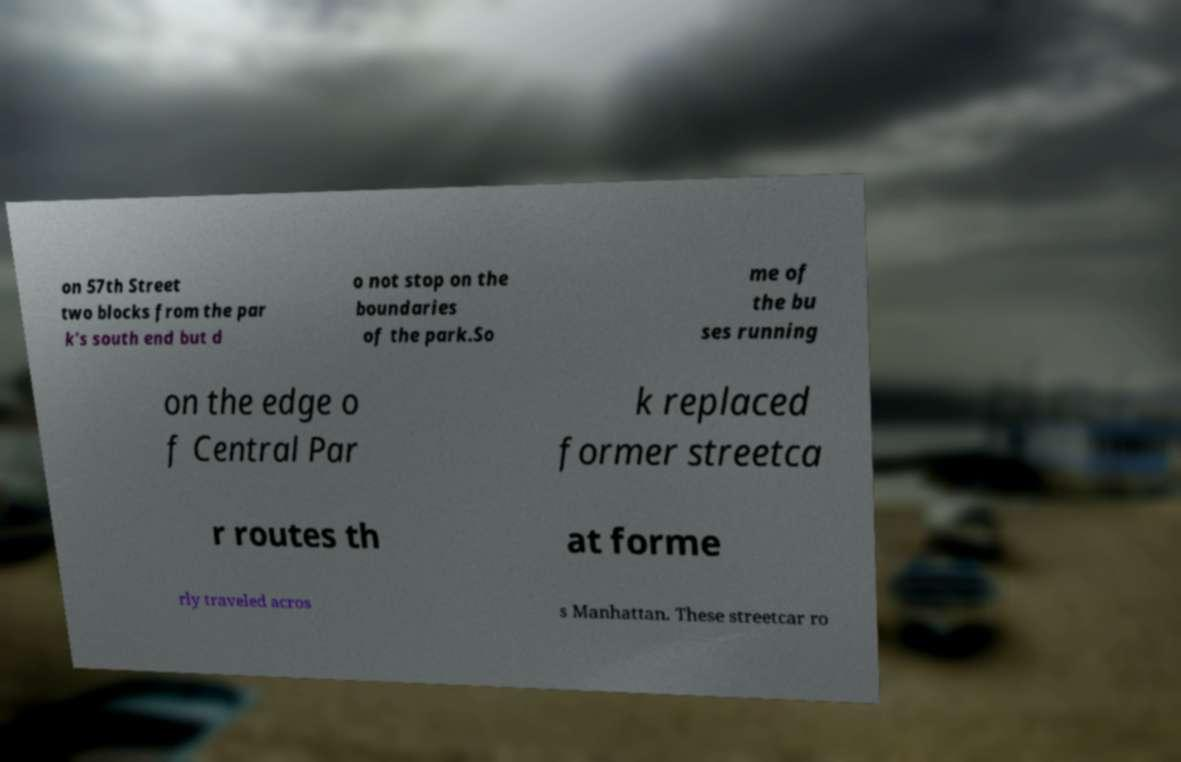Could you assist in decoding the text presented in this image and type it out clearly? on 57th Street two blocks from the par k's south end but d o not stop on the boundaries of the park.So me of the bu ses running on the edge o f Central Par k replaced former streetca r routes th at forme rly traveled acros s Manhattan. These streetcar ro 